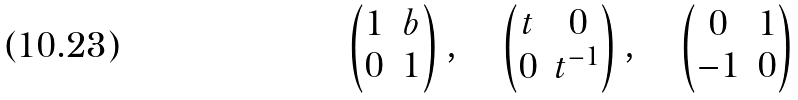Convert formula to latex. <formula><loc_0><loc_0><loc_500><loc_500>\begin{pmatrix} 1 & b \\ 0 & 1 \end{pmatrix} , \quad \begin{pmatrix} t & 0 \\ 0 & t ^ { - 1 } \end{pmatrix} , \quad \begin{pmatrix} 0 & 1 \\ - 1 & 0 \end{pmatrix}</formula> 